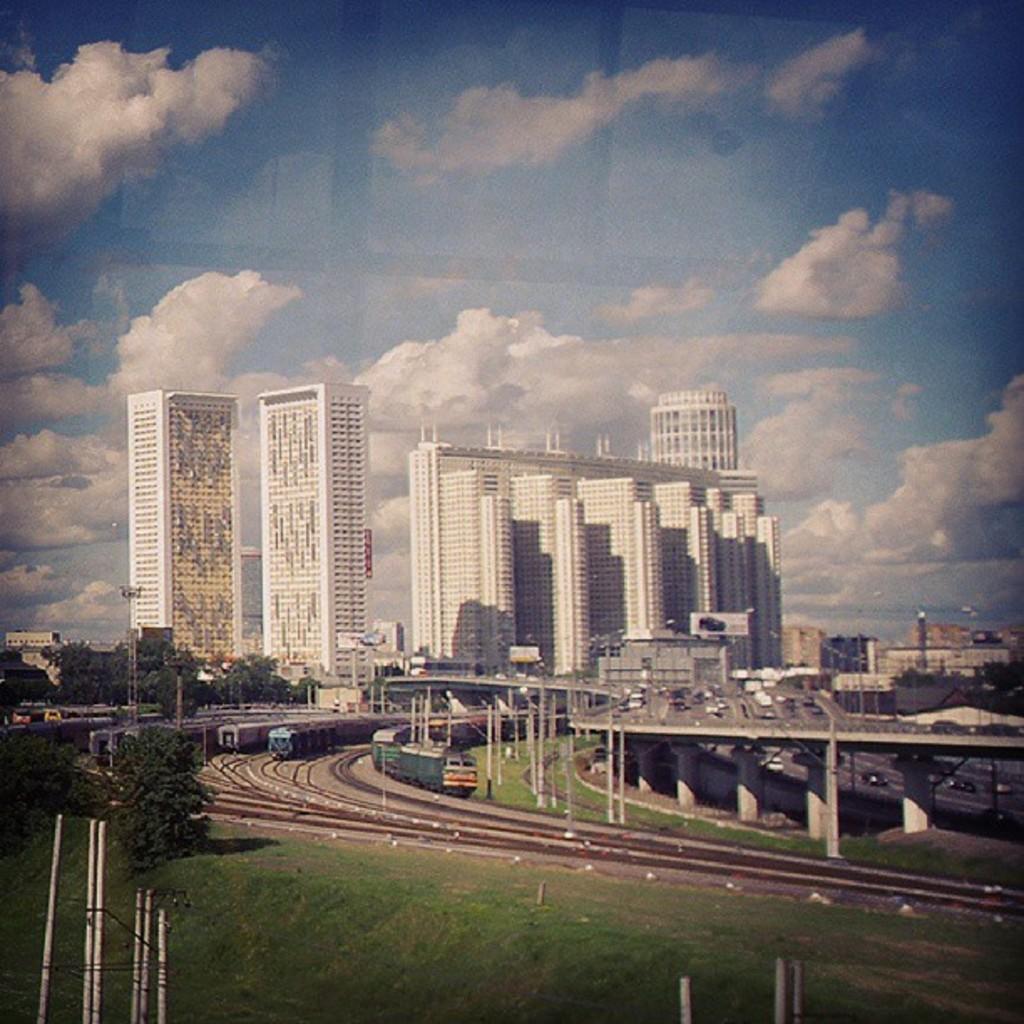In one or two sentences, can you explain what this image depicts? In the picture there is grass, trees, railway tracks, trains, bridge, vehicles and many buildings. 